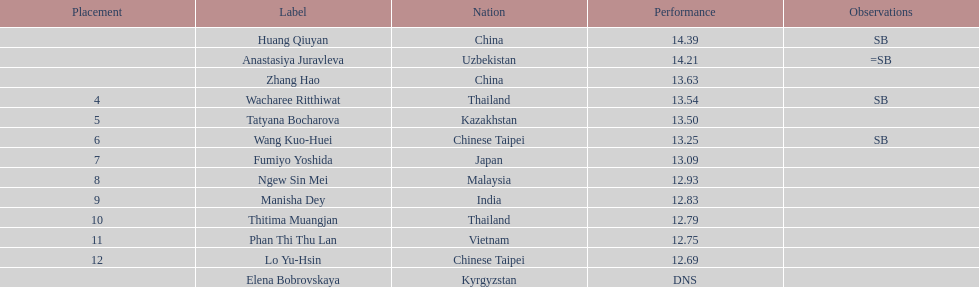00 points? 6. 